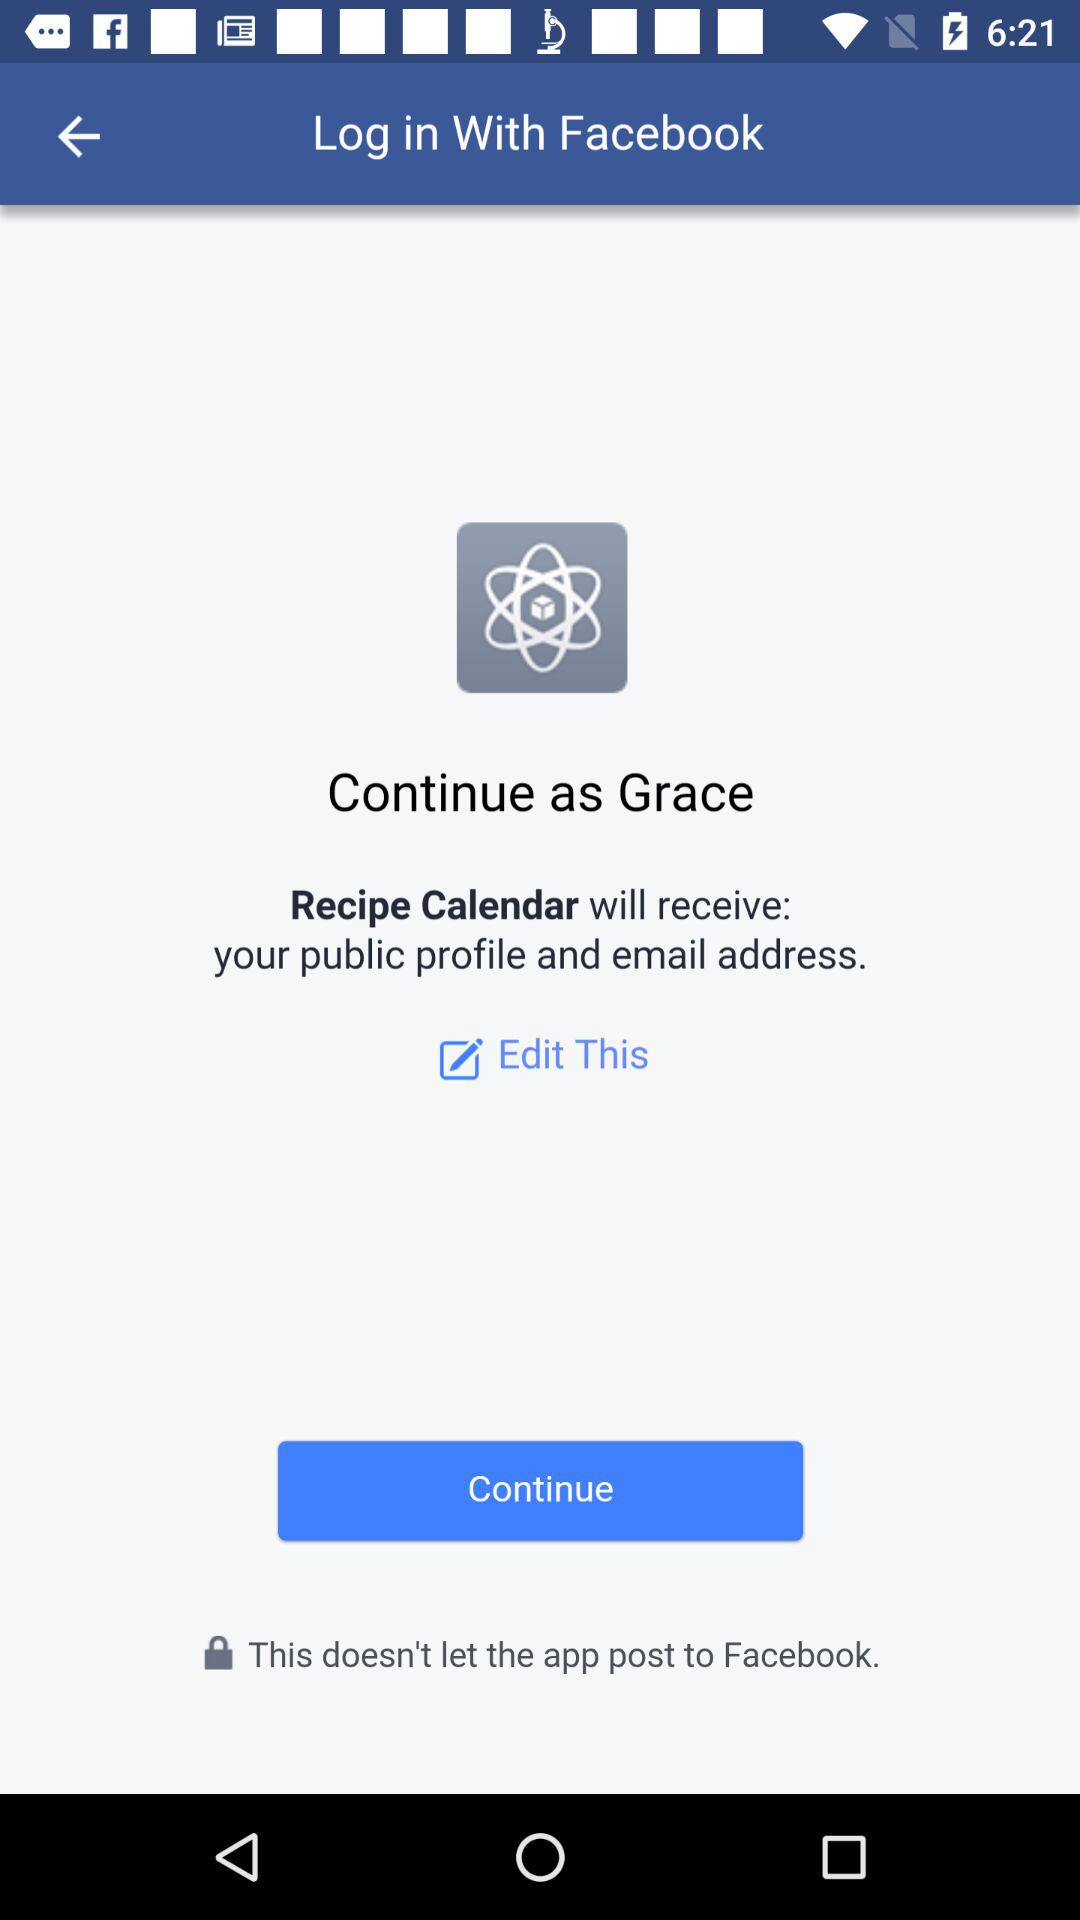Through what account can logging in be done? Logging in can be done through "Facebook" account. 